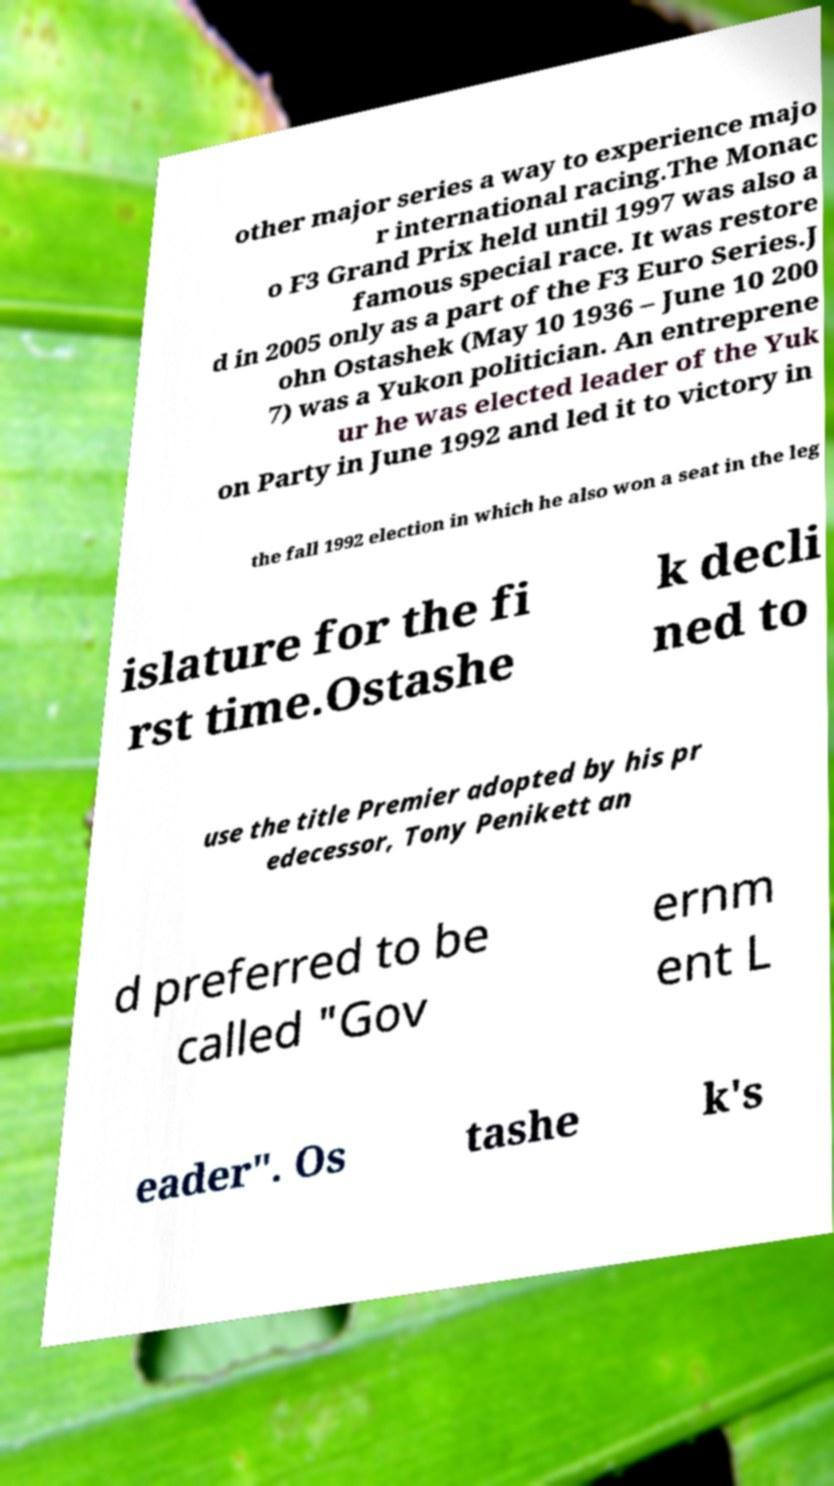I need the written content from this picture converted into text. Can you do that? other major series a way to experience majo r international racing.The Monac o F3 Grand Prix held until 1997 was also a famous special race. It was restore d in 2005 only as a part of the F3 Euro Series.J ohn Ostashek (May 10 1936 – June 10 200 7) was a Yukon politician. An entreprene ur he was elected leader of the Yuk on Party in June 1992 and led it to victory in the fall 1992 election in which he also won a seat in the leg islature for the fi rst time.Ostashe k decli ned to use the title Premier adopted by his pr edecessor, Tony Penikett an d preferred to be called "Gov ernm ent L eader". Os tashe k's 